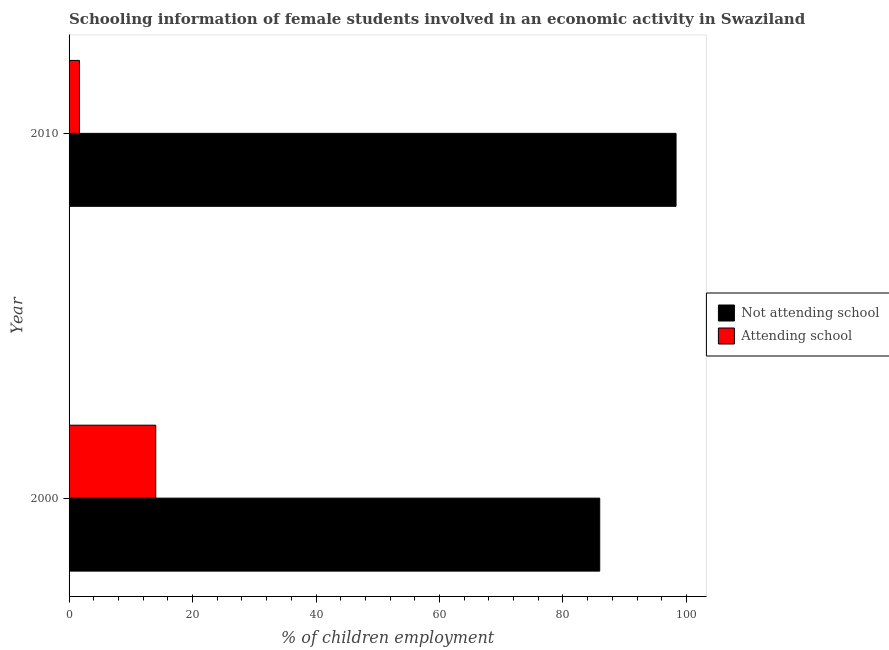How many different coloured bars are there?
Your answer should be compact. 2. Are the number of bars per tick equal to the number of legend labels?
Make the answer very short. Yes. Are the number of bars on each tick of the Y-axis equal?
Your answer should be compact. Yes. How many bars are there on the 1st tick from the top?
Your answer should be compact. 2. What is the percentage of employed females who are not attending school in 2000?
Give a very brief answer. 85.96. Across all years, what is the maximum percentage of employed females who are attending school?
Keep it short and to the point. 14.04. Across all years, what is the minimum percentage of employed females who are not attending school?
Make the answer very short. 85.96. In which year was the percentage of employed females who are not attending school maximum?
Offer a terse response. 2010. What is the total percentage of employed females who are attending school in the graph?
Make the answer very short. 15.72. What is the difference between the percentage of employed females who are attending school in 2000 and that in 2010?
Your answer should be very brief. 12.36. What is the difference between the percentage of employed females who are not attending school in 2010 and the percentage of employed females who are attending school in 2000?
Your answer should be very brief. 84.28. What is the average percentage of employed females who are attending school per year?
Offer a very short reply. 7.86. In the year 2010, what is the difference between the percentage of employed females who are not attending school and percentage of employed females who are attending school?
Provide a short and direct response. 96.64. What is the ratio of the percentage of employed females who are attending school in 2000 to that in 2010?
Your answer should be compact. 8.36. Is the percentage of employed females who are attending school in 2000 less than that in 2010?
Your answer should be very brief. No. What does the 1st bar from the top in 2000 represents?
Your answer should be compact. Attending school. What does the 2nd bar from the bottom in 2010 represents?
Your answer should be very brief. Attending school. How many years are there in the graph?
Offer a very short reply. 2. What is the difference between two consecutive major ticks on the X-axis?
Your answer should be very brief. 20. How many legend labels are there?
Your answer should be very brief. 2. What is the title of the graph?
Provide a short and direct response. Schooling information of female students involved in an economic activity in Swaziland. What is the label or title of the X-axis?
Give a very brief answer. % of children employment. What is the % of children employment in Not attending school in 2000?
Give a very brief answer. 85.96. What is the % of children employment in Attending school in 2000?
Keep it short and to the point. 14.04. What is the % of children employment in Not attending school in 2010?
Provide a succinct answer. 98.32. What is the % of children employment of Attending school in 2010?
Your answer should be compact. 1.68. Across all years, what is the maximum % of children employment in Not attending school?
Provide a short and direct response. 98.32. Across all years, what is the maximum % of children employment of Attending school?
Make the answer very short. 14.04. Across all years, what is the minimum % of children employment of Not attending school?
Provide a short and direct response. 85.96. Across all years, what is the minimum % of children employment in Attending school?
Ensure brevity in your answer.  1.68. What is the total % of children employment in Not attending school in the graph?
Keep it short and to the point. 184.28. What is the total % of children employment of Attending school in the graph?
Your response must be concise. 15.72. What is the difference between the % of children employment in Not attending school in 2000 and that in 2010?
Your response must be concise. -12.36. What is the difference between the % of children employment of Attending school in 2000 and that in 2010?
Offer a terse response. 12.36. What is the difference between the % of children employment in Not attending school in 2000 and the % of children employment in Attending school in 2010?
Your answer should be compact. 84.28. What is the average % of children employment in Not attending school per year?
Ensure brevity in your answer.  92.14. What is the average % of children employment in Attending school per year?
Give a very brief answer. 7.86. In the year 2000, what is the difference between the % of children employment in Not attending school and % of children employment in Attending school?
Provide a succinct answer. 71.92. In the year 2010, what is the difference between the % of children employment in Not attending school and % of children employment in Attending school?
Make the answer very short. 96.64. What is the ratio of the % of children employment in Not attending school in 2000 to that in 2010?
Provide a succinct answer. 0.87. What is the ratio of the % of children employment of Attending school in 2000 to that in 2010?
Give a very brief answer. 8.36. What is the difference between the highest and the second highest % of children employment in Not attending school?
Provide a short and direct response. 12.36. What is the difference between the highest and the second highest % of children employment in Attending school?
Your answer should be compact. 12.36. What is the difference between the highest and the lowest % of children employment in Not attending school?
Your response must be concise. 12.36. What is the difference between the highest and the lowest % of children employment in Attending school?
Your answer should be compact. 12.36. 